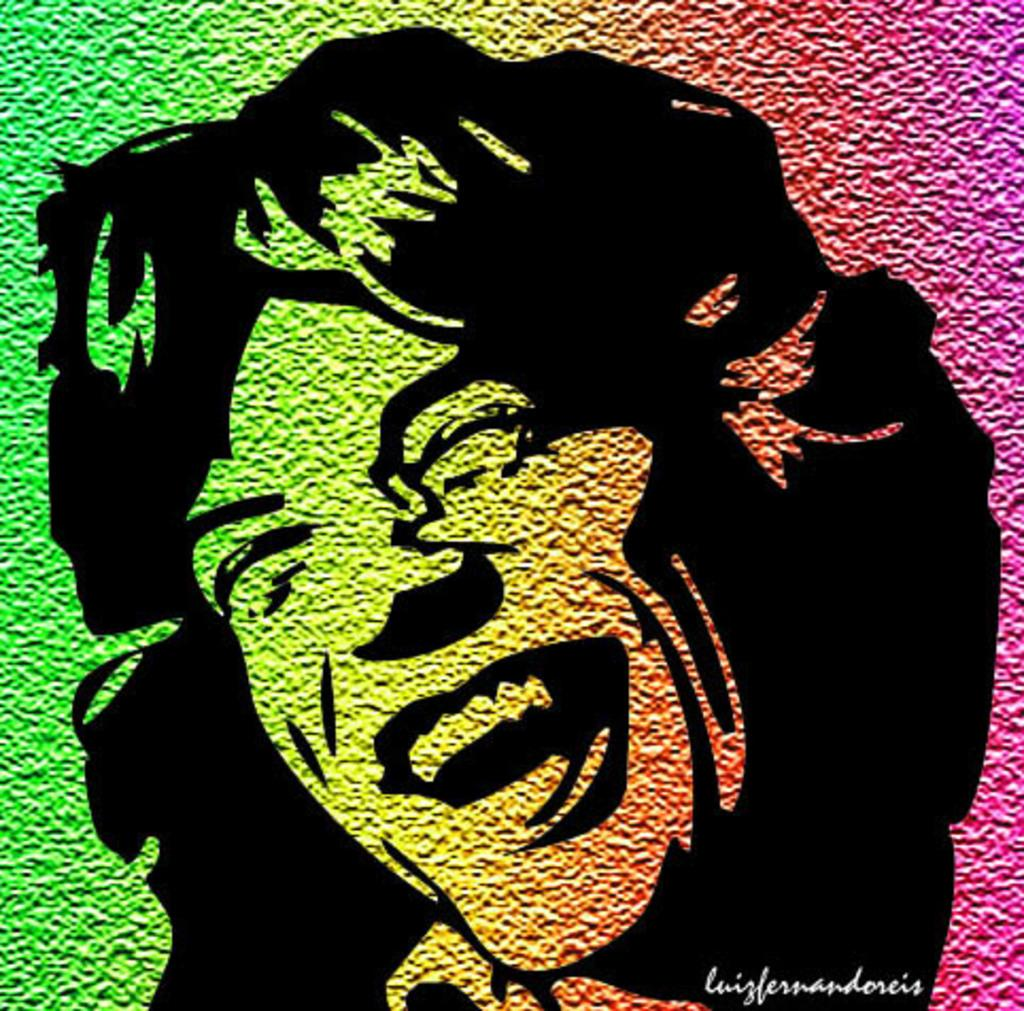What is the main subject of the image? The image contains a depiction of a person. Can you describe any additional elements in the image? There is text in the bottom right of the image. How many clovers are visible on the person's neck in the image? There are no clovers visible on the person's neck in the image. 